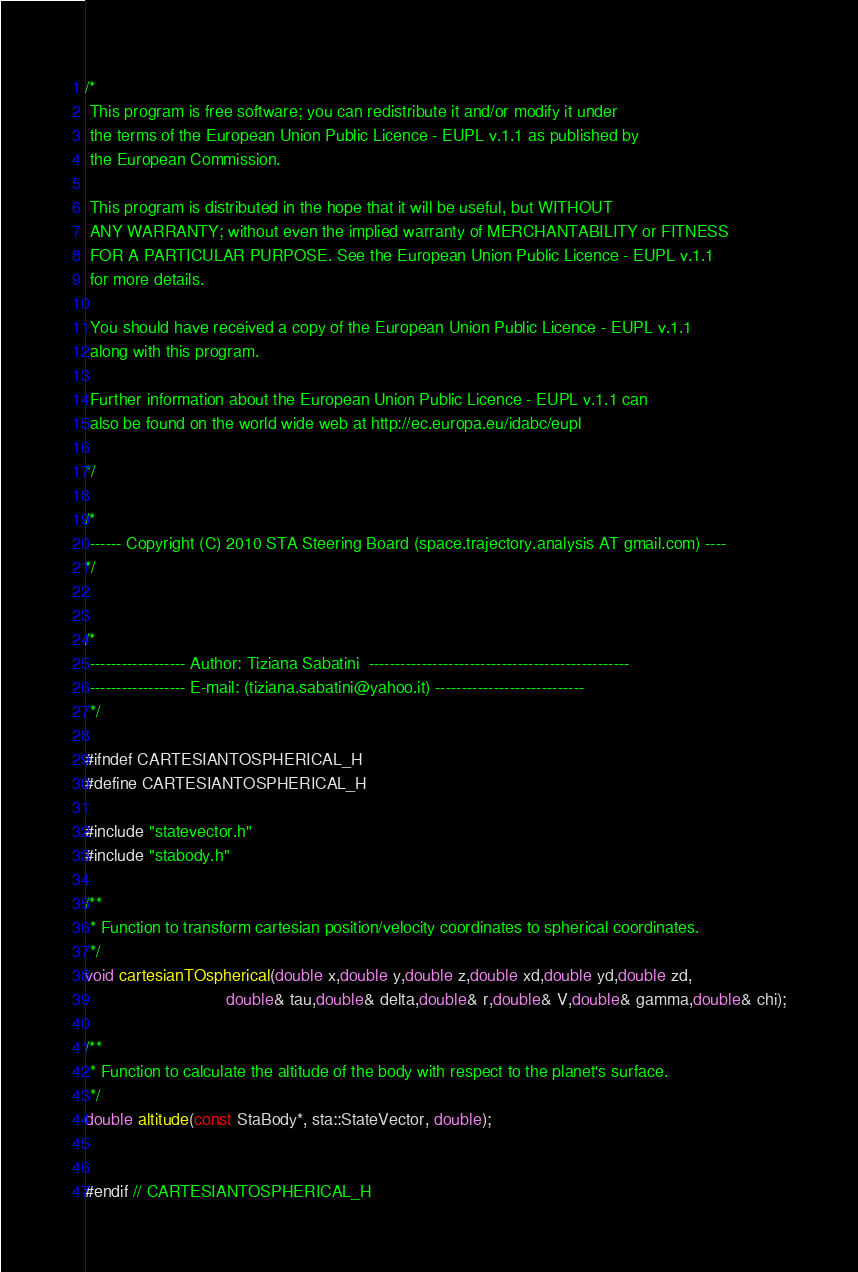<code> <loc_0><loc_0><loc_500><loc_500><_C_>/*
 This program is free software; you can redistribute it and/or modify it under
 the terms of the European Union Public Licence - EUPL v.1.1 as published by
 the European Commission.

 This program is distributed in the hope that it will be useful, but WITHOUT
 ANY WARRANTY; without even the implied warranty of MERCHANTABILITY or FITNESS
 FOR A PARTICULAR PURPOSE. See the European Union Public Licence - EUPL v.1.1
 for more details.

 You should have received a copy of the European Union Public Licence - EUPL v.1.1
 along with this program.

 Further information about the European Union Public Licence - EUPL v.1.1 can
 also be found on the world wide web at http://ec.europa.eu/idabc/eupl

*/

/*
 ------ Copyright (C) 2010 STA Steering Board (space.trajectory.analysis AT gmail.com) ----
*/


/*
 ------------------ Author: Tiziana Sabatini  -------------------------------------------------
 ------------------ E-mail: (tiziana.sabatini@yahoo.it) ----------------------------
 */

#ifndef CARTESIANTOSPHERICAL_H
#define CARTESIANTOSPHERICAL_H

#include "statevector.h"
#include "stabody.h"

/**
 * Function to transform cartesian position/velocity coordinates to spherical coordinates.
 */
void cartesianTOspherical(double x,double y,double z,double xd,double yd,double zd,
                              double& tau,double& delta,double& r,double& V,double& gamma,double& chi);

/**
 * Function to calculate the altitude of the body with respect to the planet's surface.
 */
double altitude(const StaBody*, sta::StateVector, double);


#endif // CARTESIANTOSPHERICAL_H
</code> 